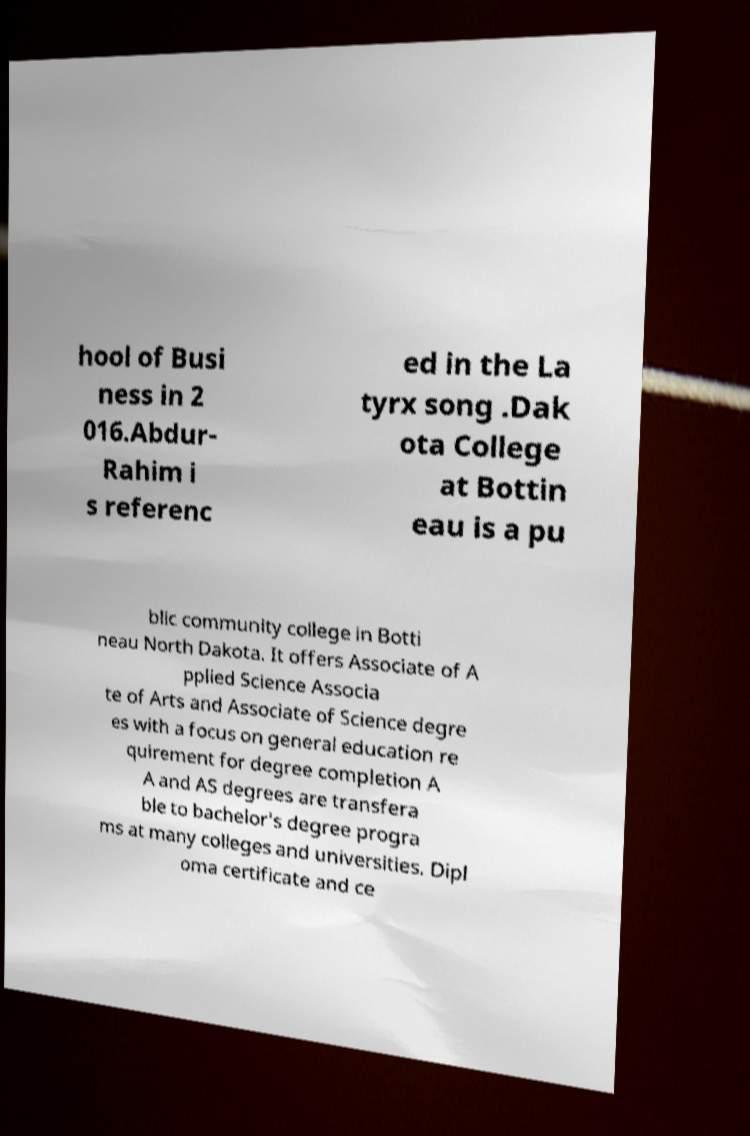Can you read and provide the text displayed in the image?This photo seems to have some interesting text. Can you extract and type it out for me? hool of Busi ness in 2 016.Abdur- Rahim i s referenc ed in the La tyrx song .Dak ota College at Bottin eau is a pu blic community college in Botti neau North Dakota. It offers Associate of A pplied Science Associa te of Arts and Associate of Science degre es with a focus on general education re quirement for degree completion A A and AS degrees are transfera ble to bachelor's degree progra ms at many colleges and universities. Dipl oma certificate and ce 